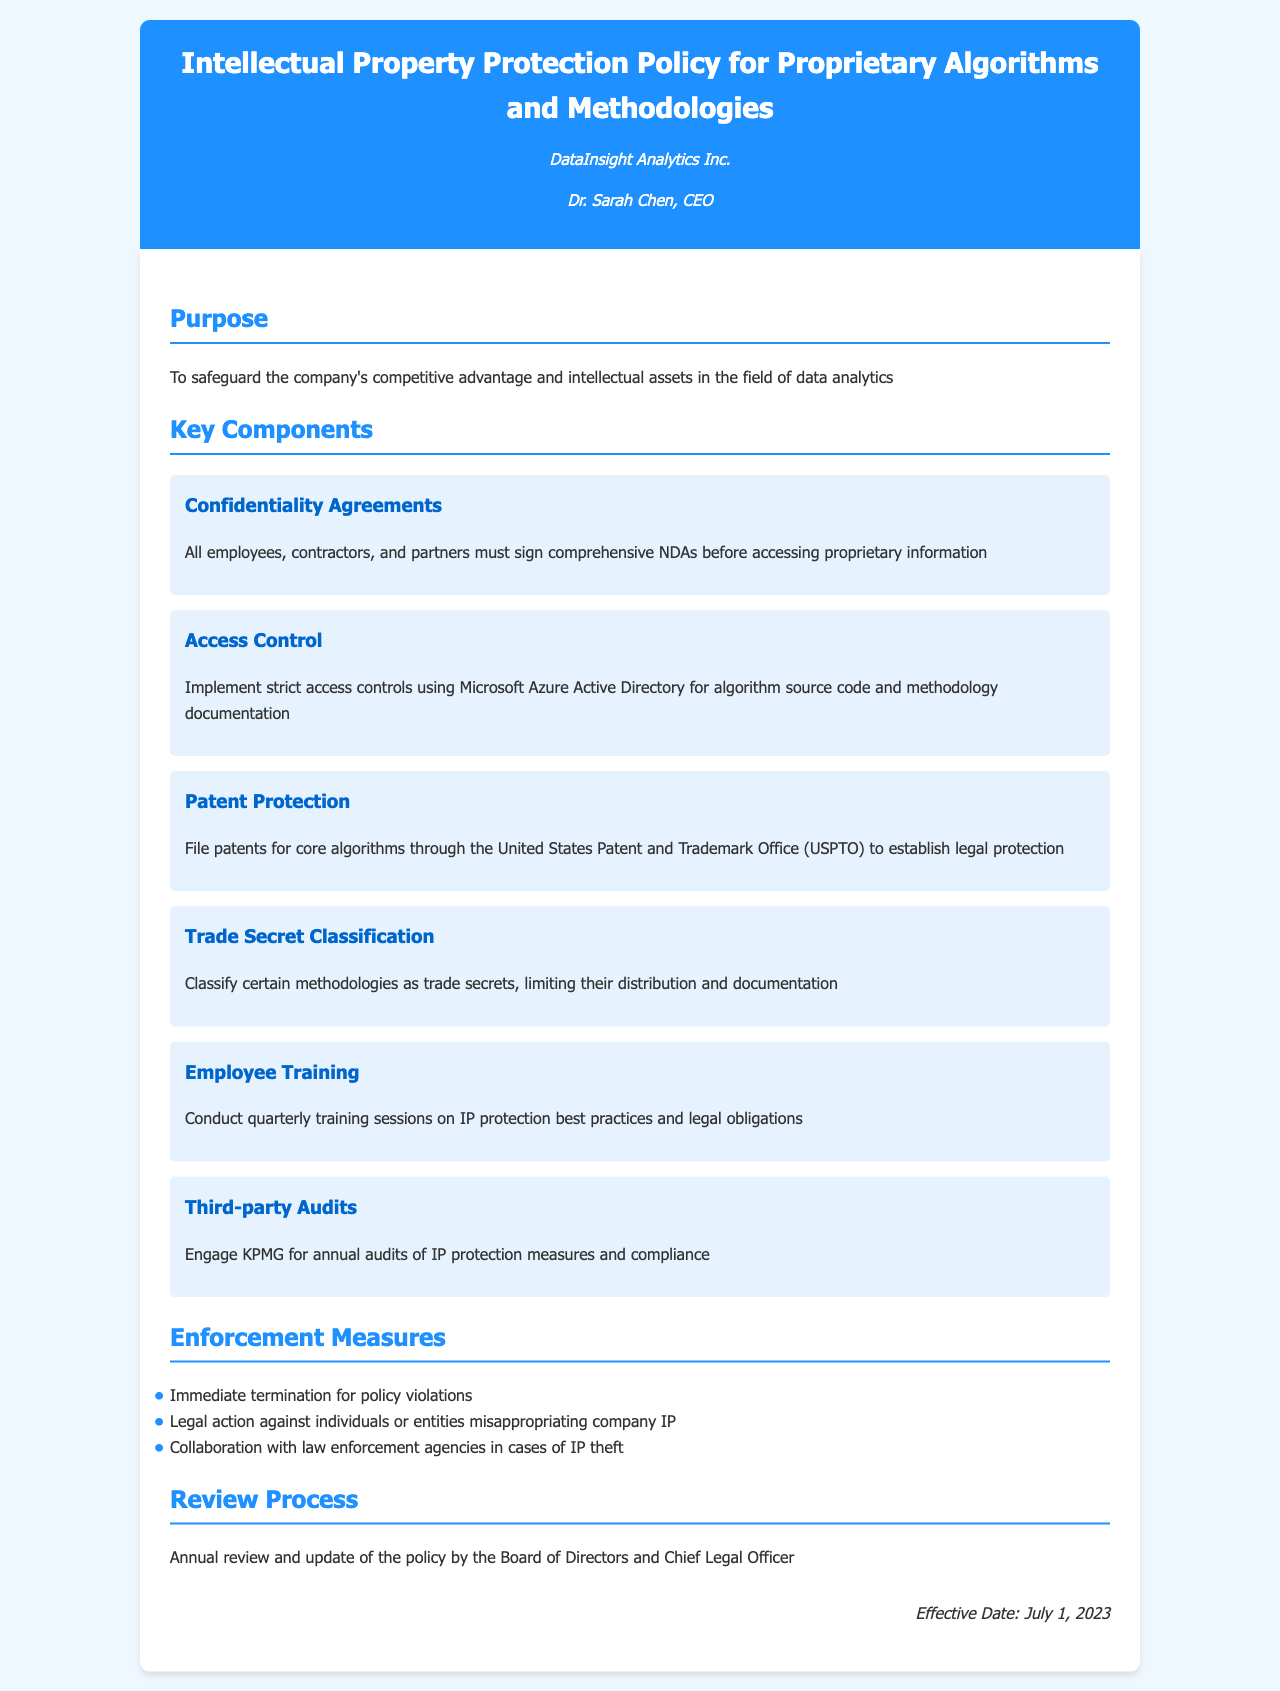What is the purpose of the policy? The purpose is stated as safeguarding the company's competitive advantage and intellectual assets in the field of data analytics.
Answer: To safeguard the company's competitive advantage and intellectual assets in the field of data analytics Who must sign confidentiality agreements? The document specifies that all employees, contractors, and partners must sign comprehensive NDAs before accessing proprietary information.
Answer: All employees, contractors, and partners What does the policy classify as trade secrets? The policy states that certain methodologies are classified as trade secrets, limiting their distribution and documentation.
Answer: Certain methodologies What is the effective date of the policy? The effective date is mentioned at the end of the document.
Answer: July 1, 2023 Who conducts the annual audits of IP protection measures? The document indicates that KPMG is engaged for annual audits of IP protection measures and compliance.
Answer: KPMG What action is taken for immediate policy violations? The policy clearly states that immediate termination is the consequence for policy violations.
Answer: Immediate termination What type of training is conducted quarterly? The document mentions that quarterly training sessions on IP protection best practices and legal obligations are conducted.
Answer: Training sessions Who reviews the policy annually? The annual review and update of the policy is conducted by the Board of Directors and Chief Legal Officer.
Answer: Board of Directors and Chief Legal Officer What is a method of legal protection mentioned in the document? The document states that filing patents for core algorithms establishes legal protection.
Answer: Filing patents 